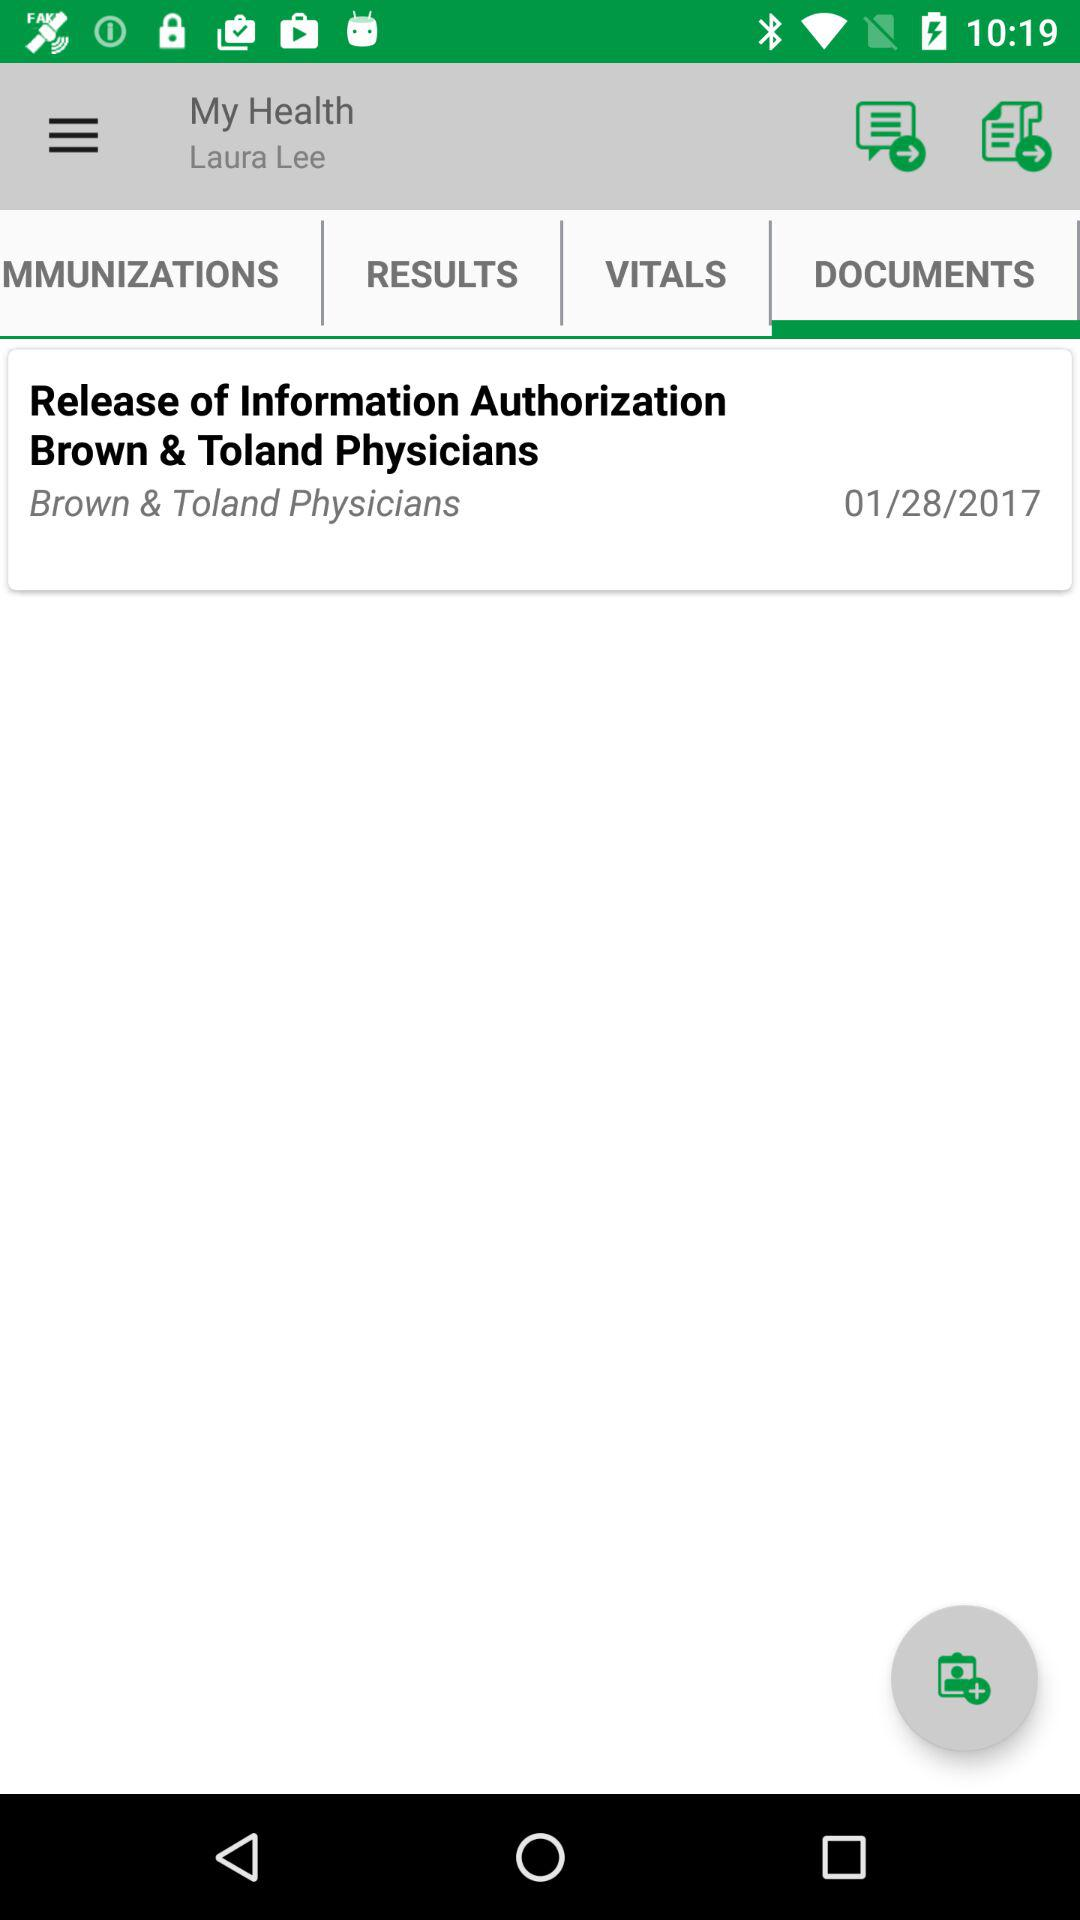What is the physicians name? The physicians name is Brown & Toland. 